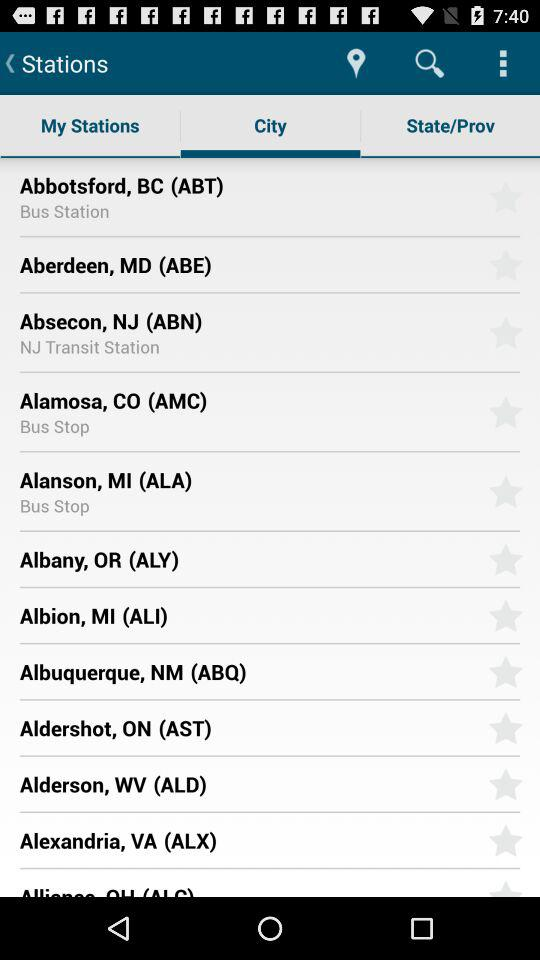Is Alanson a bus stop?
When the provided information is insufficient, respond with <no answer>. <no answer> 